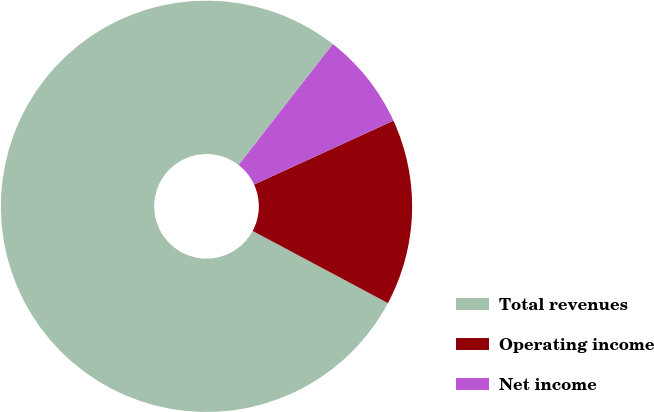Convert chart. <chart><loc_0><loc_0><loc_500><loc_500><pie_chart><fcel>Total revenues<fcel>Operating income<fcel>Net income<nl><fcel>77.73%<fcel>14.64%<fcel>7.63%<nl></chart> 